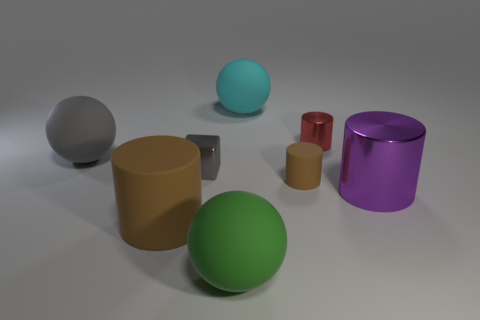What is the size of the other brown cylinder that is made of the same material as the tiny brown cylinder? The other brown cylinder in the image appears to be significantly larger than the tiny brown cylinder. While the small cylinder could be considered miniature, the larger brown one is comparable in size to the other objects around it, such as the purple cylinder and the green sphere, suggesting a medium to large size in relation to its surroundings. 